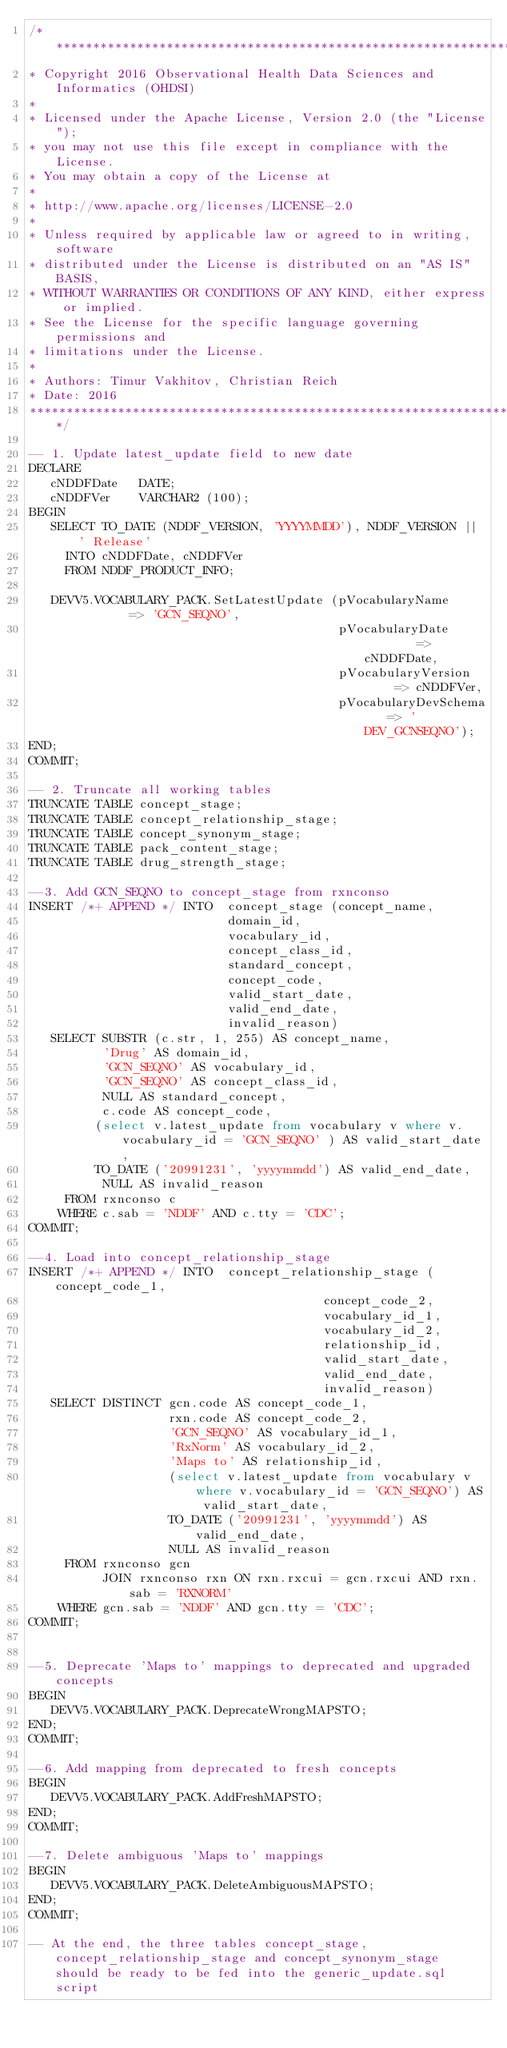Convert code to text. <code><loc_0><loc_0><loc_500><loc_500><_SQL_>/**************************************************************************
* Copyright 2016 Observational Health Data Sciences and Informatics (OHDSI)
*
* Licensed under the Apache License, Version 2.0 (the "License");
* you may not use this file except in compliance with the License.
* You may obtain a copy of the License at
*
* http://www.apache.org/licenses/LICENSE-2.0
*
* Unless required by applicable law or agreed to in writing, software
* distributed under the License is distributed on an "AS IS" BASIS,
* WITHOUT WARRANTIES OR CONDITIONS OF ANY KIND, either express or implied.
* See the License for the specific language governing permissions and
* limitations under the License.
* 
* Authors: Timur Vakhitov, Christian Reich
* Date: 2016
**************************************************************************/

-- 1. Update latest_update field to new date 
DECLARE
   cNDDFDate   DATE;
   cNDDFVer    VARCHAR2 (100);
BEGIN
   SELECT TO_DATE (NDDF_VERSION, 'YYYYMMDD'), NDDF_VERSION || ' Release'
     INTO cNDDFDate, cNDDFVer
     FROM NDDF_PRODUCT_INFO;

   DEVV5.VOCABULARY_PACK.SetLatestUpdate (pVocabularyName        => 'GCN_SEQNO',
                                          pVocabularyDate        => cNDDFDate,
                                          pVocabularyVersion     => cNDDFVer,
                                          pVocabularyDevSchema   => 'DEV_GCNSEQNO');
END;
COMMIT;

-- 2. Truncate all working tables
TRUNCATE TABLE concept_stage;
TRUNCATE TABLE concept_relationship_stage;
TRUNCATE TABLE concept_synonym_stage;
TRUNCATE TABLE pack_content_stage;
TRUNCATE TABLE drug_strength_stage;

--3. Add GCN_SEQNO to concept_stage from rxnconso
INSERT /*+ APPEND */ INTO  concept_stage (concept_name,
                           domain_id,
                           vocabulary_id,
                           concept_class_id,
                           standard_concept,
                           concept_code,
                           valid_start_date,
                           valid_end_date,
                           invalid_reason)
   SELECT SUBSTR (c.str, 1, 255) AS concept_name,
          'Drug' AS domain_id,
          'GCN_SEQNO' AS vocabulary_id,
          'GCN_SEQNO' AS concept_class_id,
          NULL AS standard_concept,
          c.code AS concept_code,
		 (select v.latest_update from vocabulary v where v.vocabulary_id = 'GCN_SEQNO' ) AS valid_start_date,
		 TO_DATE ('20991231', 'yyyymmdd') AS valid_end_date,
          NULL AS invalid_reason
     FROM rxnconso c
    WHERE c.sab = 'NDDF' AND c.tty = 'CDC';
COMMIT;

--4. Load into concept_relationship_stage
INSERT /*+ APPEND */ INTO  concept_relationship_stage (concept_code_1,
                                        concept_code_2,
                                        vocabulary_id_1,
                                        vocabulary_id_2,
                                        relationship_id,
                                        valid_start_date,
                                        valid_end_date,
                                        invalid_reason)
   SELECT DISTINCT gcn.code AS concept_code_1,
                   rxn.code AS concept_code_2,
                   'GCN_SEQNO' AS vocabulary_id_1,
                   'RxNorm' AS vocabulary_id_2,
                   'Maps to' AS relationship_id,
				   (select v.latest_update from vocabulary v where v.vocabulary_id = 'GCN_SEQNO') AS valid_start_date,
                   TO_DATE ('20991231', 'yyyymmdd') AS valid_end_date,
                   NULL AS invalid_reason
     FROM rxnconso gcn
          JOIN rxnconso rxn ON rxn.rxcui = gcn.rxcui AND rxn.sab = 'RXNORM'
    WHERE gcn.sab = 'NDDF' AND gcn.tty = 'CDC';
COMMIT;	 


--5. Deprecate 'Maps to' mappings to deprecated and upgraded concepts
BEGIN
   DEVV5.VOCABULARY_PACK.DeprecateWrongMAPSTO;
END;
COMMIT;	

--6. Add mapping from deprecated to fresh concepts
BEGIN
   DEVV5.VOCABULARY_PACK.AddFreshMAPSTO;
END;
COMMIT;		 

--7. Delete ambiguous 'Maps to' mappings
BEGIN
   DEVV5.VOCABULARY_PACK.DeleteAmbiguousMAPSTO;
END;
COMMIT;

-- At the end, the three tables concept_stage, concept_relationship_stage and concept_synonym_stage should be ready to be fed into the generic_update.sql script		</code> 